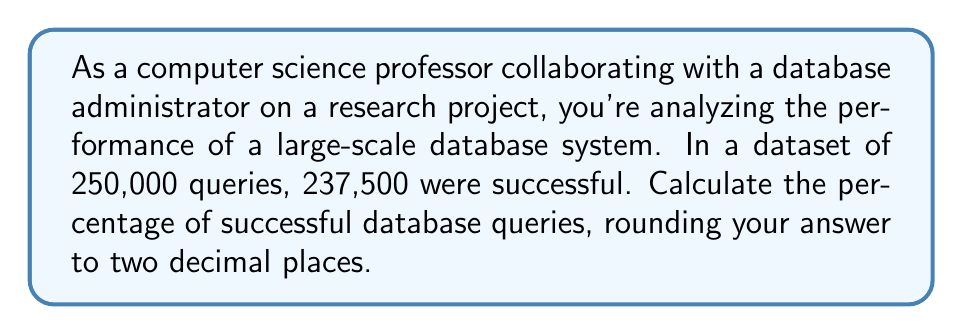Help me with this question. To calculate the percentage of successful database queries, we need to follow these steps:

1. Identify the total number of queries and the number of successful queries:
   Total queries: 250,000
   Successful queries: 237,500

2. Use the formula for calculating percentage:
   $$ \text{Percentage} = \frac{\text{Number of successful queries}}{\text{Total number of queries}} \times 100\% $$

3. Plug in the values:
   $$ \text{Percentage} = \frac{237,500}{250,000} \times 100\% $$

4. Perform the division:
   $$ \text{Percentage} = 0.95 \times 100\% $$

5. Multiply by 100 to get the percentage:
   $$ \text{Percentage} = 95\% $$

The result is already rounded to two decimal places, so no further rounding is necessary.
Answer: 95.00% 